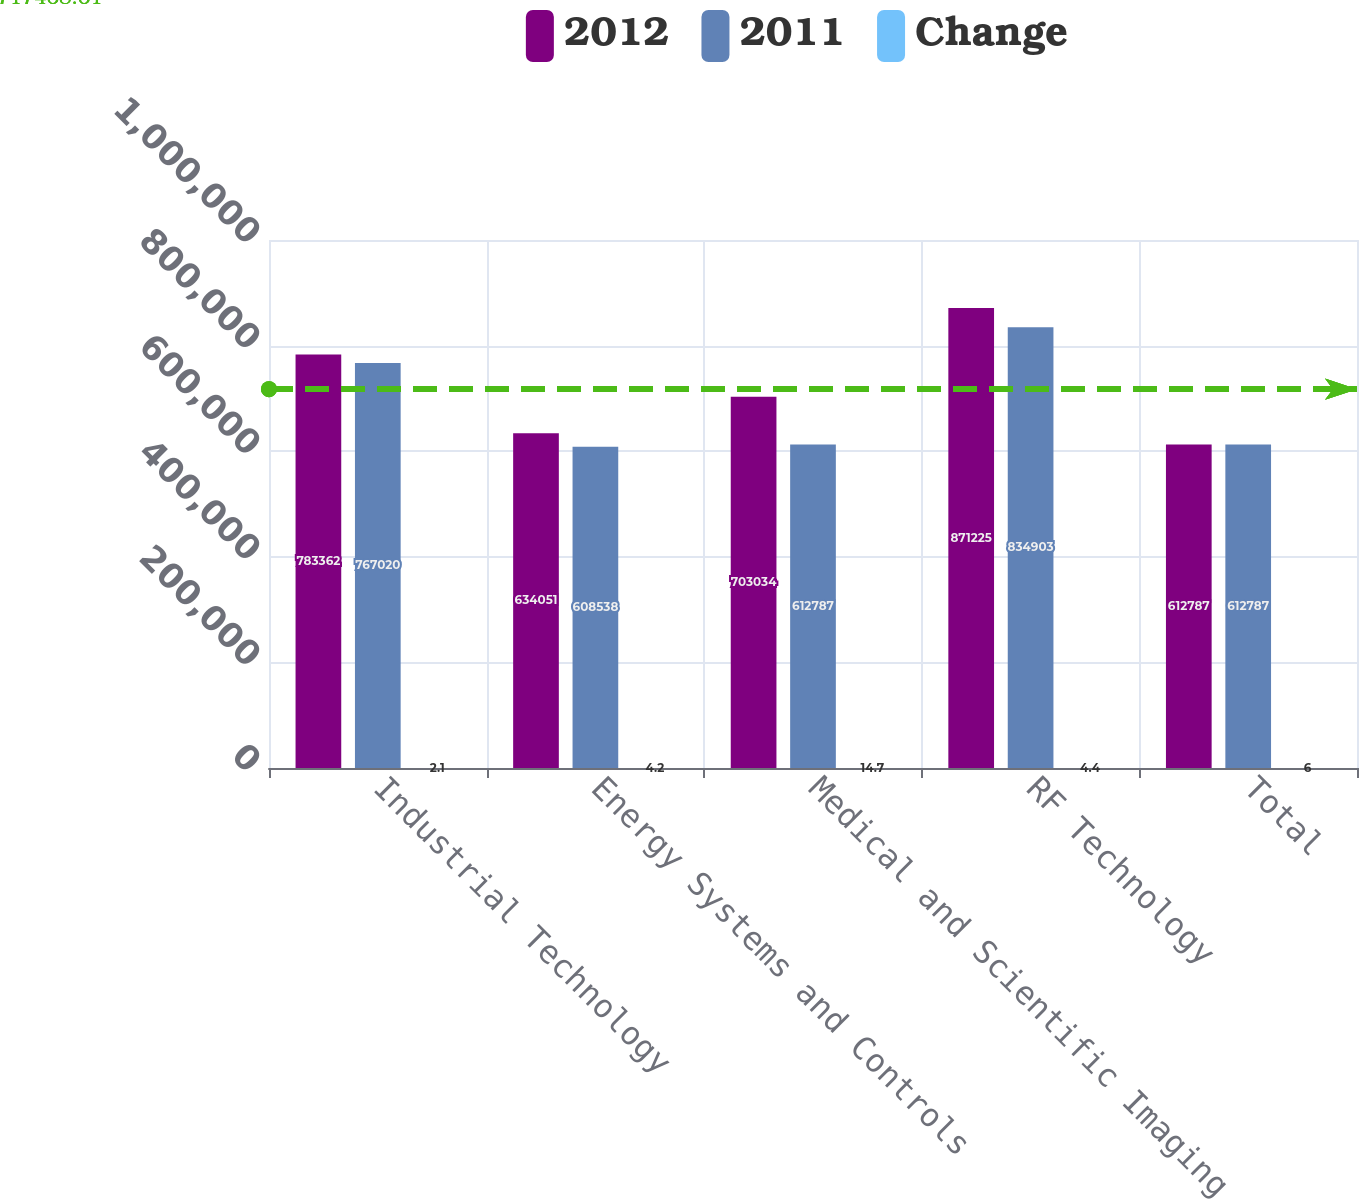<chart> <loc_0><loc_0><loc_500><loc_500><stacked_bar_chart><ecel><fcel>Industrial Technology<fcel>Energy Systems and Controls<fcel>Medical and Scientific Imaging<fcel>RF Technology<fcel>Total<nl><fcel>2012<fcel>783362<fcel>634051<fcel>703034<fcel>871225<fcel>612787<nl><fcel>2011<fcel>767020<fcel>608538<fcel>612787<fcel>834903<fcel>612787<nl><fcel>Change<fcel>2.1<fcel>4.2<fcel>14.7<fcel>4.4<fcel>6<nl></chart> 